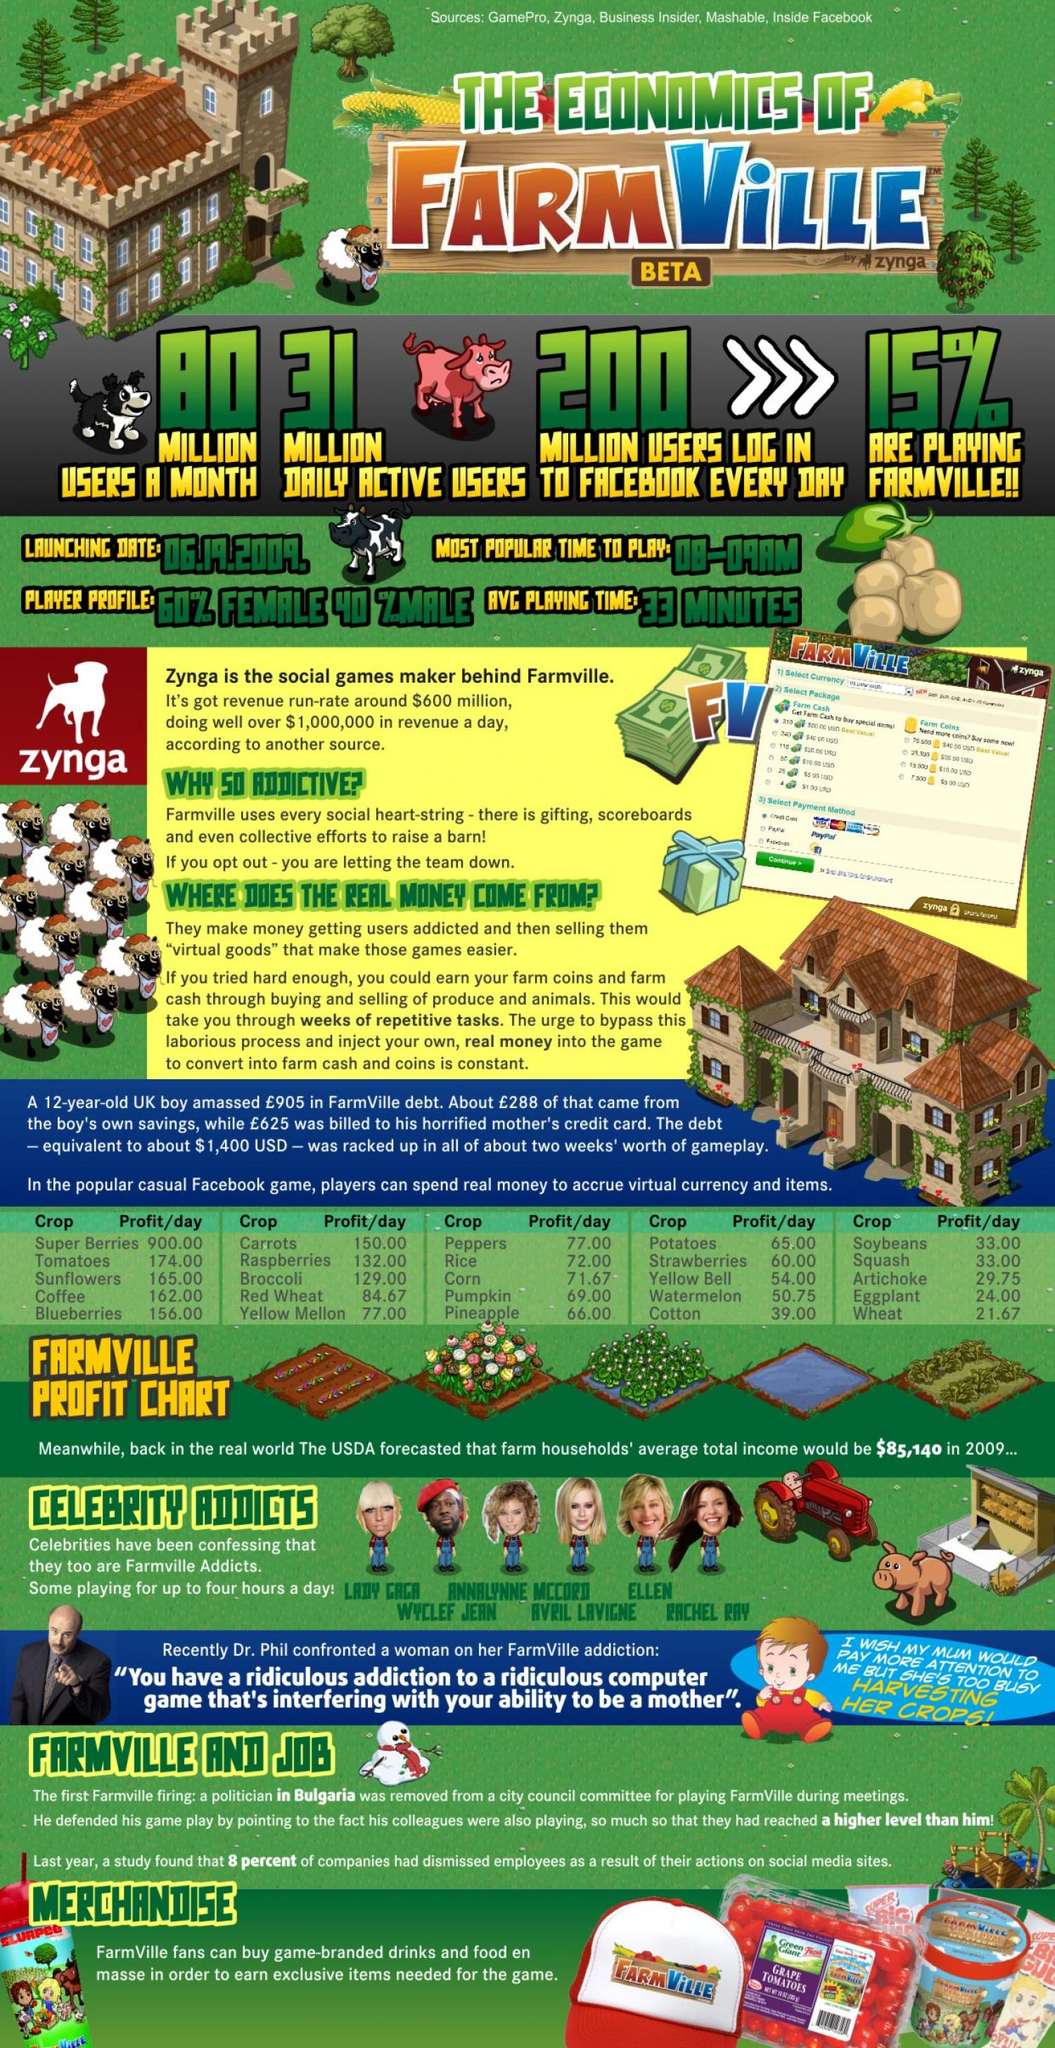Outline some significant characteristics in this image. The profit chart in Farmville shows that certain items, such as sunflowers, tomatoes, and super berries, have a higher profit per day compared to coffee. In the Farmville profit chart, certain items such as soybeans and squash generate a profit of 33.00 per day. In the profit chart for Farmville, items with a profit range of 50-59 per day include watermelon and yellow bell. If we were to survey 10 players of the game Farmville, it is estimated that approximately 6 of them would be female. Out of the 10 player profiles of Farmville, it is estimated that 4 of them would be male. 